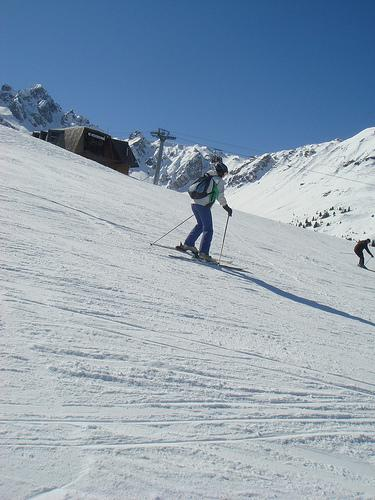Describe the main activity being performed in the image. Skiers are going down the slopes with ski tracks on the snow and a ski lift in the background. Write about the environment in the image paying attention to one particular feature. Pine trees are grouped together in the distance with snow covering the ground and ski tracks across it. Discuss the infrastructure present in the image. There is a brown ski lodge at the top of the mountain and an electric pole providing energy near the ski lift. Describe the weather conditions visible in the picture. The picture shows bright and sunny weather with a cloudless blue sky above the snowy landscape. Talk about one specific skier's stance and what they are doing. One skier is bending over while going down the hill, leaning forward as they glide through the snow. Write a sentence about a specific skier and what they are wearing. A skier is wearing a white jacket and blue pants while carrying black ski poles and wearing a blue helmet. Mention the variety of colors present in the image. The image contains colors like white snow, clear blue sky, dark brown lodge, and skiers in different outfits. Describe the image by focusing on the shadows observed and their significance. The image captures the shadow of a skier in a white jacket on the ground, indicating a bright light source. Mention one significant aspect of the image regarding the landscape. The image features snow-capped mountains in the background with a clear blue sky above. Provide a brief overview of the scene captured in the image. The image shows skiers enjoying a day on the slopes with a ski lift, mountains, and pine trees in view. Spot the yellow ski lift. None of the provided captions mention the color of the ski lift, so stating that it is yellow is misleading. Identify a person snowboarding down the slope. All the captions mention skiers, not snowboarders, so this instruction is misleading since it introduces a new and incorrect activity in the image. Where is the group of people gathered near the ski lodge? None of the provided captions mention a group of people gathered near the ski lodge, implying that this scene is not in the image. Observe a snowstorm occurring in the image. The captions describe a "clear blue sky", "bright blue clear sky", and "a cloudless blue sky" which indicates that there is no snowstorm in the image. Is there a dog playing in the snow nearby? No, it's not mentioned in the image. Find the green trees in the background. The captions only mentions "grouped pine trees" and "trees in the distance" without specifying their color, so assuming they are green is misleading. Can you see the skier wearing orange pants? There are captions describing skiers wearing blue and purple pants, but none of them mention orange pants. Thus, asking for a skier with orange pants is misleading. Find a skier performing a jump in the air. The captions describe various skiers going down the slope but none of them mention a skier mid-jump or in the air. Locate the rocky mountain without any snow. All mentioned mountains and mountain tops in the captions have snow on them, so a rocky mountain without snow doesn't exist in the scene. 